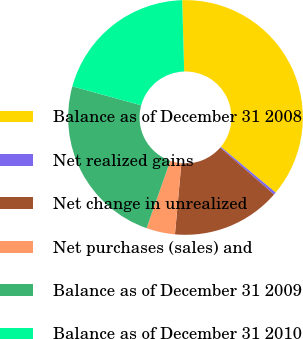Convert chart. <chart><loc_0><loc_0><loc_500><loc_500><pie_chart><fcel>Balance as of December 31 2008<fcel>Net realized gains<fcel>Net change in unrealized<fcel>Net purchases (sales) and<fcel>Balance as of December 31 2009<fcel>Balance as of December 31 2010<nl><fcel>36.5%<fcel>0.34%<fcel>15.04%<fcel>3.95%<fcel>23.89%<fcel>20.28%<nl></chart> 